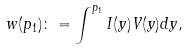Convert formula to latex. <formula><loc_0><loc_0><loc_500><loc_500>w ( p _ { 1 } ) \colon = \int ^ { p _ { 1 } } I ( y ) V ( y ) d y ,</formula> 